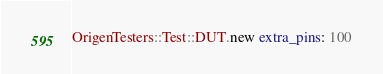Convert code to text. <code><loc_0><loc_0><loc_500><loc_500><_Ruby_>OrigenTesters::Test::DUT.new extra_pins: 100
</code> 